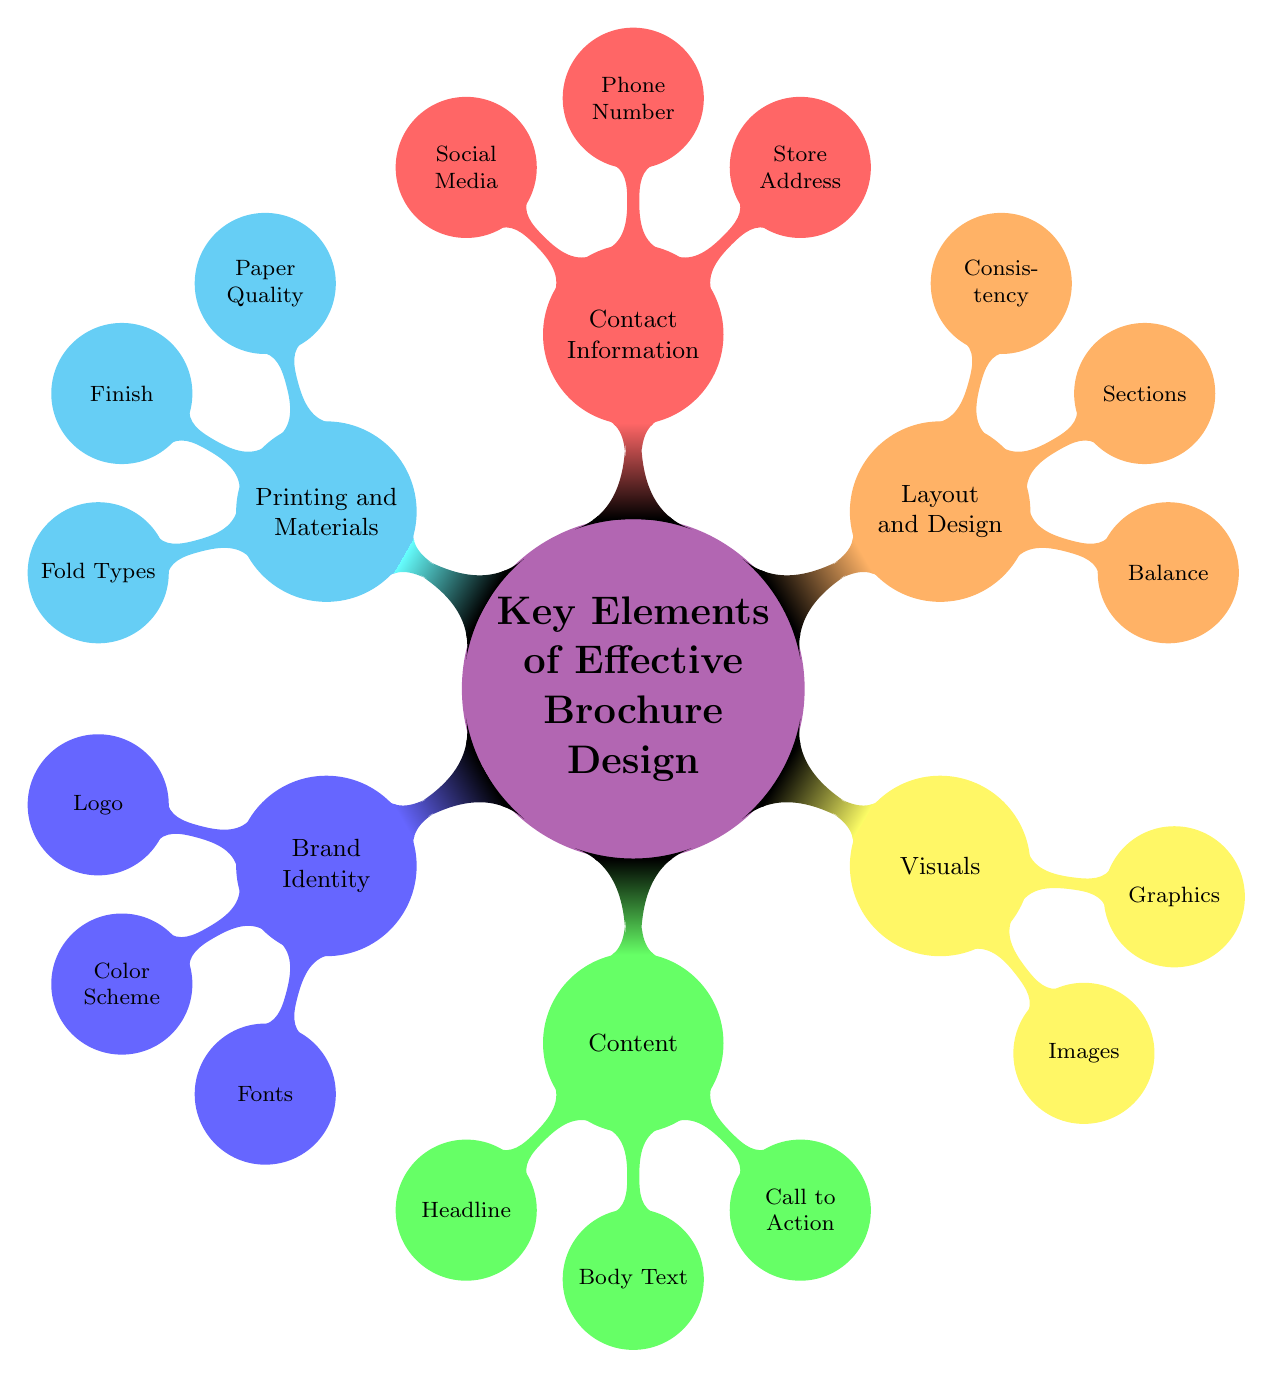What's a key element that relates to the store's visual representation? The diagram lists "Visuals" as a major component of brochure design, which focuses on the representation of the boutique through imagery.
Answer: Visuals How many sections are within the "Content" node? The "Content" node contains three sub-nodes: Headline, Body Text, and Call to Action. Therefore, it has three sections.
Answer: 3 Which node contains the sub-node "Call to Action"? The "Call to Action" sub-node is part of the "Content" node, which indicates its relevance to the overall messaging and objectives within the brochure.
Answer: Content What should be included in the "Contact Information" node? The "Contact Information" node lists three components: Store Address, Phone Number, and Social Media, all aimed at providing customers with ways to reach the boutique.
Answer: Store Address, Phone Number, Social Media Which color represents the "Layout and Design" section? In the mind map, the "Layout and Design" section is represented by the orange color, indicating its distinct importance in terms of organization and structure within the brochure.
Answer: Orange What does "Balance" refer to in the context of brochure design? "Balance" under the "Layout and Design" section emphasizes the importance of a visually appealing layout that does not overcrowd or underutilize space, ensuring readability.
Answer: Balance Why might "Paper Quality" be important for a boutique's brochure? "Paper Quality," under the "Printing and Materials" category, reflects the boutique's value and commitment to quality, influencing customer perception through the tactile feel of the brochure.
Answer: High-quality paper How does "Consistency" in design impact customer perception? "Consistency" in design reinforces brand recognition and professionalism, as indicated in its placement under the "Layout and Design" node, ensuring that all elements work harmoniously together.
Answer: Reinforces brand recognition 